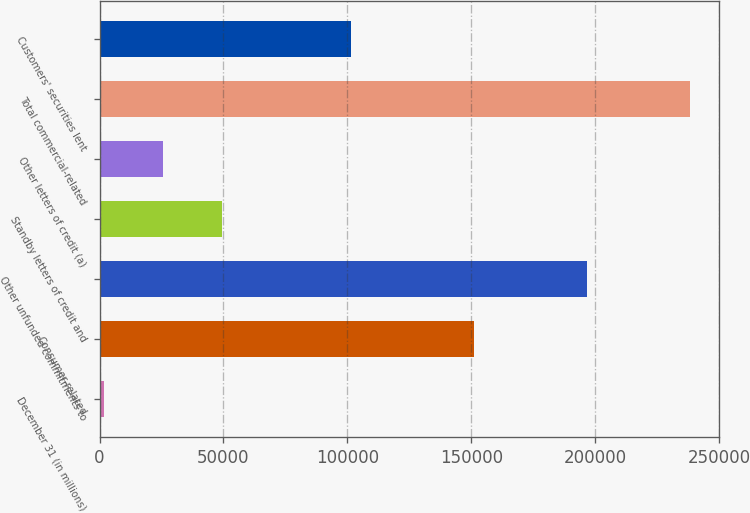Convert chart. <chart><loc_0><loc_0><loc_500><loc_500><bar_chart><fcel>December 31 (in millions)<fcel>Consumer-related<fcel>Other unfunded commitments to<fcel>Standby letters of credit and<fcel>Other letters of credit (a)<fcel>Total commercial-related<fcel>Customers' securities lent<nl><fcel>2002<fcel>151138<fcel>196654<fcel>49225.6<fcel>25613.8<fcel>238120<fcel>101503<nl></chart> 